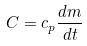Convert formula to latex. <formula><loc_0><loc_0><loc_500><loc_500>C = c _ { p } \frac { d m } { d t }</formula> 